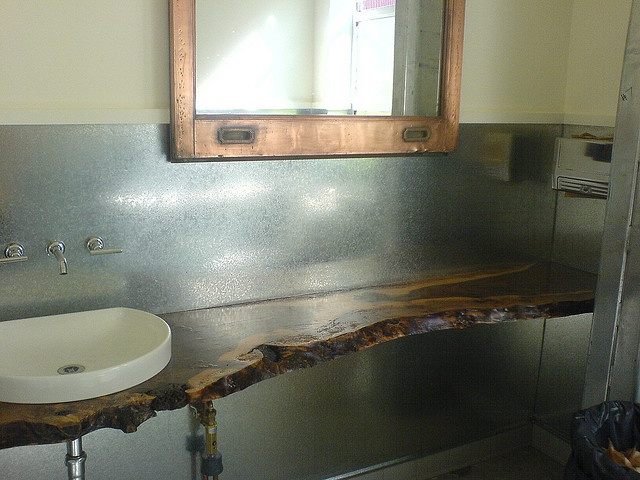Describe the objects in this image and their specific colors. I can see a sink in tan, darkgray, gray, and black tones in this image. 